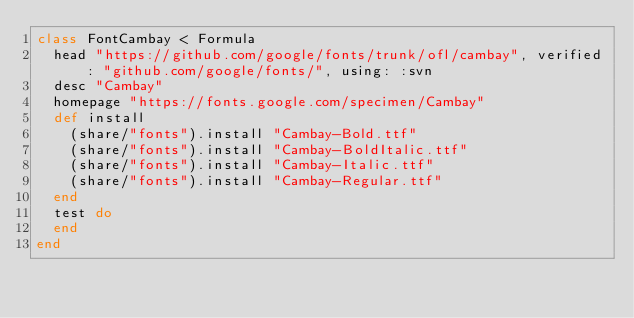<code> <loc_0><loc_0><loc_500><loc_500><_Ruby_>class FontCambay < Formula
  head "https://github.com/google/fonts/trunk/ofl/cambay", verified: "github.com/google/fonts/", using: :svn
  desc "Cambay"
  homepage "https://fonts.google.com/specimen/Cambay"
  def install
    (share/"fonts").install "Cambay-Bold.ttf"
    (share/"fonts").install "Cambay-BoldItalic.ttf"
    (share/"fonts").install "Cambay-Italic.ttf"
    (share/"fonts").install "Cambay-Regular.ttf"
  end
  test do
  end
end
</code> 